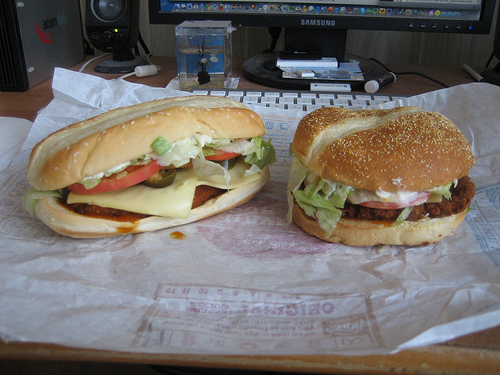Please provide the bounding box coordinate of the region this sentence describes: Small green lettuce under bun. Coordinates: [0.03, 0.5, 0.17, 0.62]. This marks a small, vibrant green lettuce partially tucked under the bun, adding fresh greens to the hamburger. 